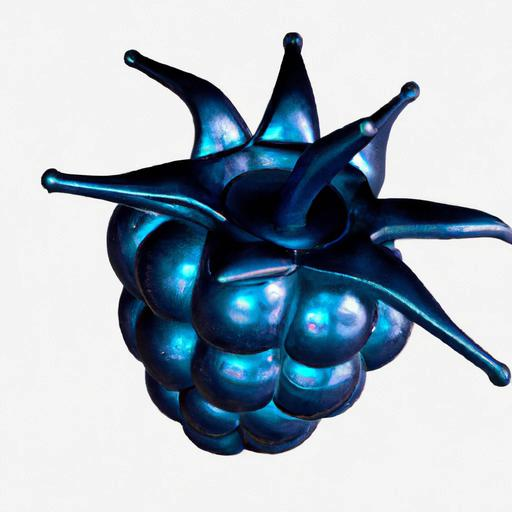Can you tell me what the object in the image is meant to represent? The object appears to be a stylized or conceptual version of a fruit, possibly a raspberry, with exaggerated forms and a vibrant iridescent blue color. Does this image have any artistic significance? Certainly, its exaggerated contours and the unusual color choice may evoke a sense of the surreal, challenging our perceptions of natural objects. It could be interpreted as a statement on the beauty of biodiversity or a creative exploration of forms found in nature. 